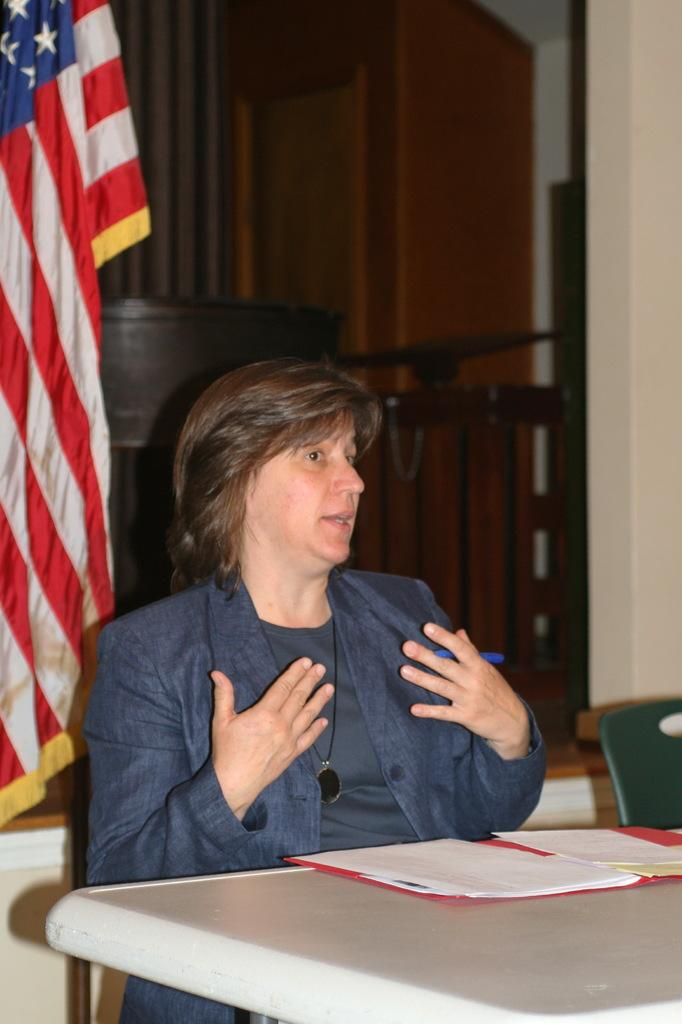What is the woman in the image doing? The woman is sitting in the image. What is located behind the woman? There is a table behind the woman. What is on the table? There are papers on the table. What can be seen in the background of the image? There is a flag visible in the background. What property does the woman own in the image? There is no information about the woman owning any property in the image. 